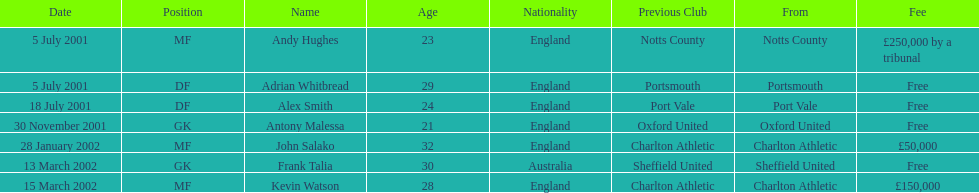Did andy hughes or john salako command the largest fee? Andy Hughes. 